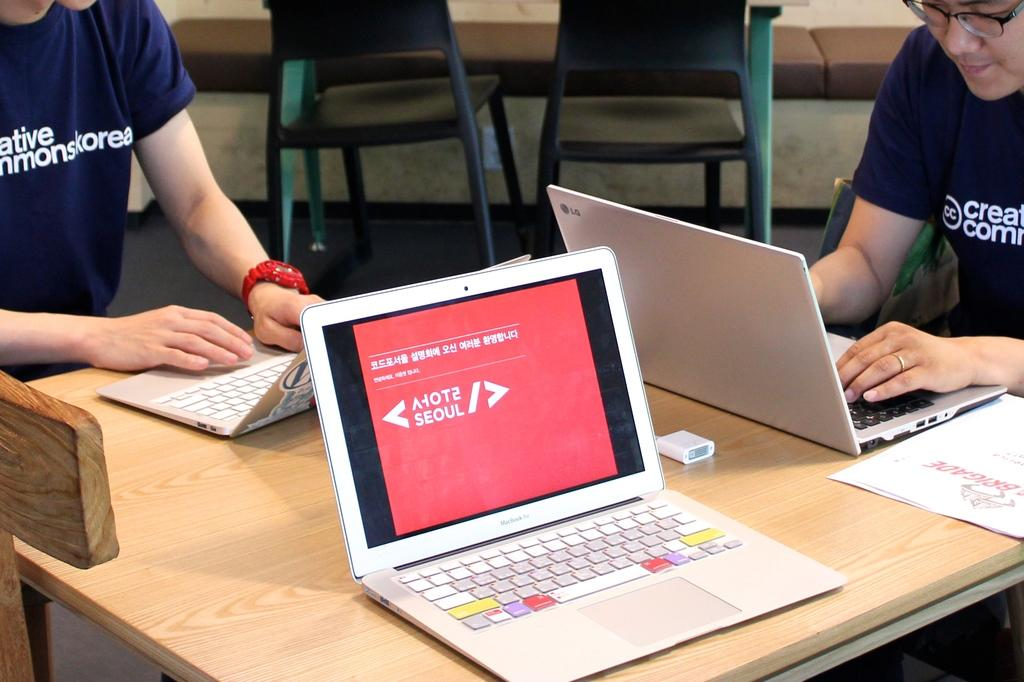What is the main piece of furniture in the image? There is a table in the image. What is placed on the table? There are three laptops on the table. How many people are in the image? There are two men in the image. Where are the men positioned in relation to the table? One man is on the right side and one is on the left side. What are the men doing in the image? The men are looking at the laptops. Can you describe the background of the image? There are two chairs in the background of the image. What type of rhythm can be heard coming from the stick in the image? There is no stick or rhythm present in the image. 